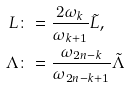<formula> <loc_0><loc_0><loc_500><loc_500>L & \colon = \frac { 2 \omega _ { k } } { \omega _ { k + 1 } } \tilde { L } , \\ \Lambda & \colon = \frac { \omega _ { 2 n - k } } { \omega _ { 2 n - k + 1 } } \tilde { \Lambda }</formula> 